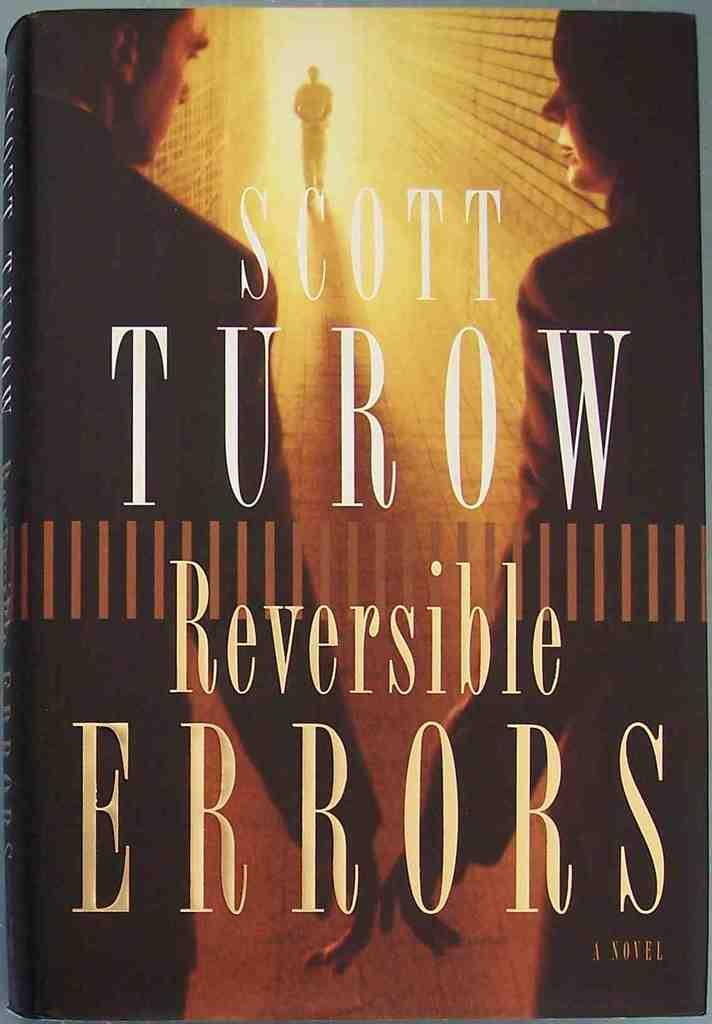<image>
Provide a brief description of the given image. Three people are seen on the cover of Reversible Errors by Scott Turow. 